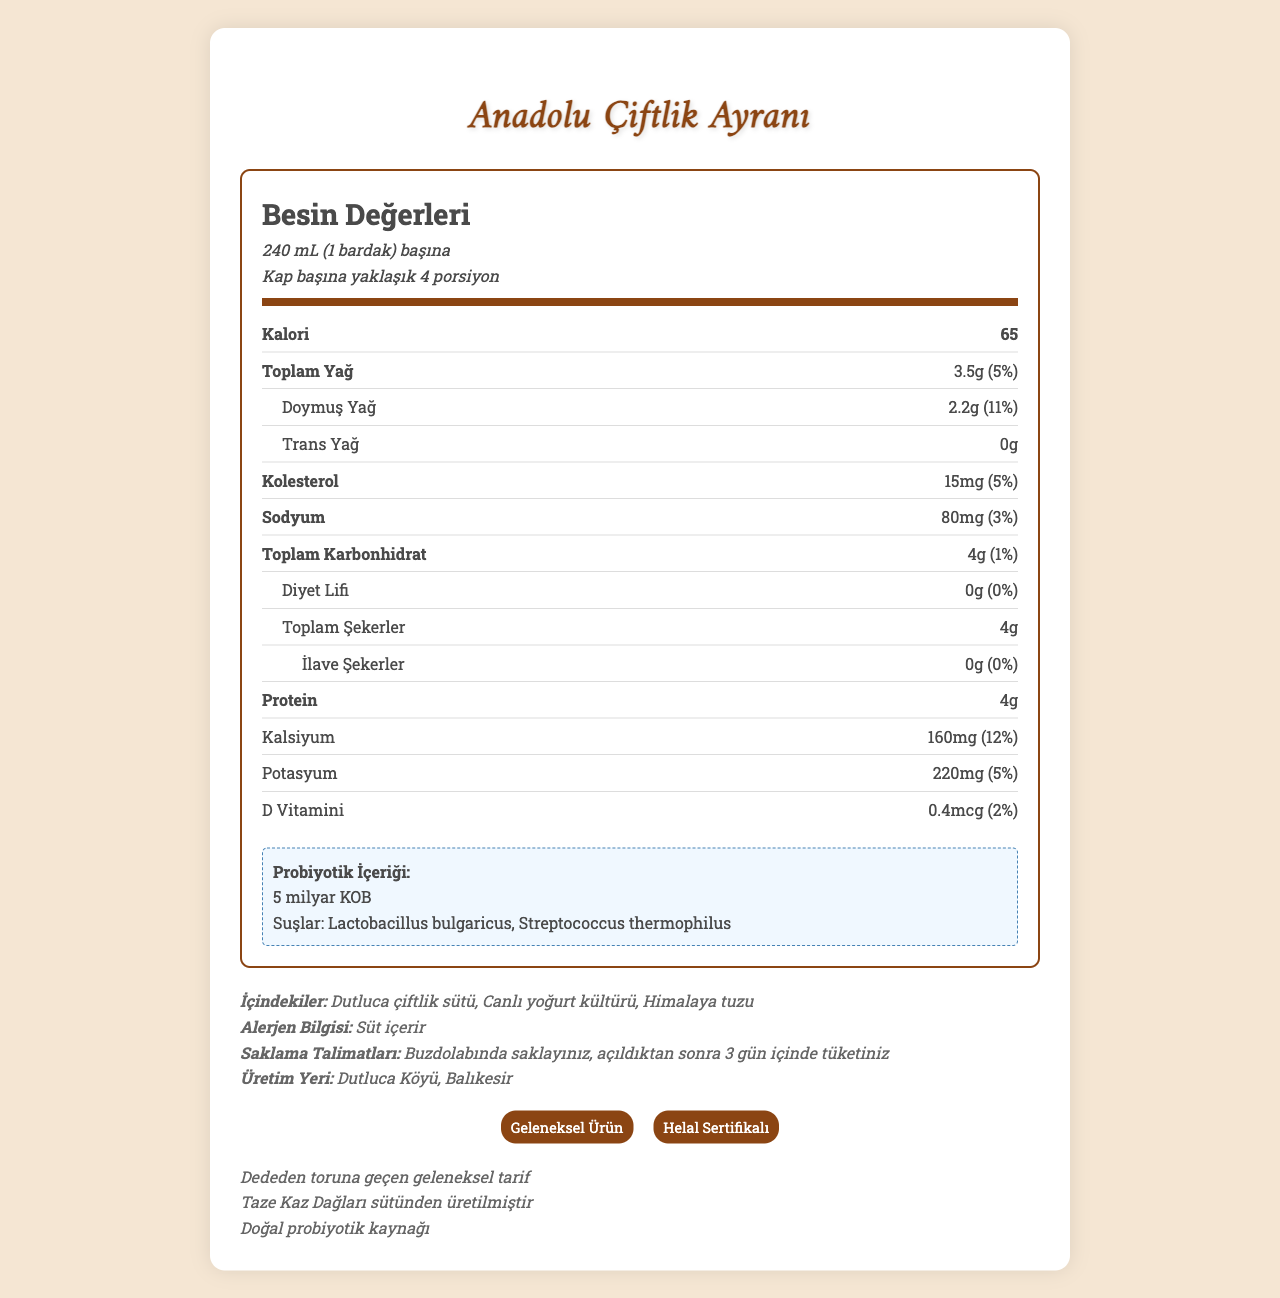how many calories are in one serving of Anadolu Çiftlik Ayranı? The document states that there are 65 calories per serving size of 240 mL (1 bardak).
Answer: 65 calories what is the daily value percentage of calcium in one serving? The document lists the daily value percentage of calcium per serving as 12%.
Answer: 12% what are the probiotic strains present in the ayran? The document mentions that the probiotic strains present in the ayran are Lactobacillus bulgaricus and Streptococcus thermophilus.
Answer: Lactobacillus bulgaricus and Streptococcus thermophilus how much protein is in one serving? The document specifies that there are 4g of protein in one serving of 240 mL.
Answer: 4g where is Anadolu Çiftlik Ayranı produced? The document states that the ayran is produced in Dutluca Köyü, Balıkesir.
Answer: Dutluca Köyü, Balıkesir what should be the storage condition for the ayran? The document advises storing the ayran in the refrigerator and consuming it within 3 days after opening.
Answer: Buzdolabında saklayınız, açıldıktan sonra 3 gün içinde tüketiniz what is the total fat content in one serving of Anadolu Çiftlik Ayranı? The document indicates that the total fat content per serving is 3.5g.
Answer: 3.5g which of the following is NOT included in the ingredients list for Anadolu Çiftlik Ayranı? A. Dutluca çiftlik sütü B. Canlı yoğurt kültürü C. Şeker The document lists 'Dutluca çiftlik sütü', 'Canlı yoğurt kültürü', and 'Himalaya tuzu' as ingredients, and does not include 'Şeker'.
Answer: C which certification does Anadolu Çiftlik Ayranı have? I. Geleneksel Ürün II. Organik Ürün III. Helal Sertifikalı The document states that the ayran is certified as 'Geleneksel Ürün' and 'Helal Sertifikalı'; 'Organik Ürün' is not mentioned.
Answer: I and III is the ayran free from trans fats? According to the document, the trans fat content is 0g per serving.
Answer: Yes summarize the main idea of this document The main purpose of the document is to offer a comprehensive overview of nutritional values, ingredients, production details, and additional information about Anadolu Çiftlik Ayranı, emphasizing its benefits and traditional qualities.
Answer: The document provides detailed nutrition facts, ingredients, storage instructions, and certifications for Anadolu Çiftlik Ayranı. It highlights the high probiotic content and calcium levels and specifies that the ayran is made from fresh Dutluca farm milk and is traditionally produced with no added sugars. how much dietary fiber does one serving of ayran provide? The document mentions that the dietary fiber content per serving is 0g.
Answer: 0g what is the flavor of the ayran? The document does not provide any information about the flavor of the ayran, only its nutritional content and ingredients.
Answer: Cannot be determined what is the amount of vitamin D in one serving? The document states that there are 0.4mcg of vitamin D in one serving, which is 2% of the daily value.
Answer: 0.4mcg 